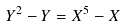Convert formula to latex. <formula><loc_0><loc_0><loc_500><loc_500>Y ^ { 2 } - Y = X ^ { 5 } - X</formula> 